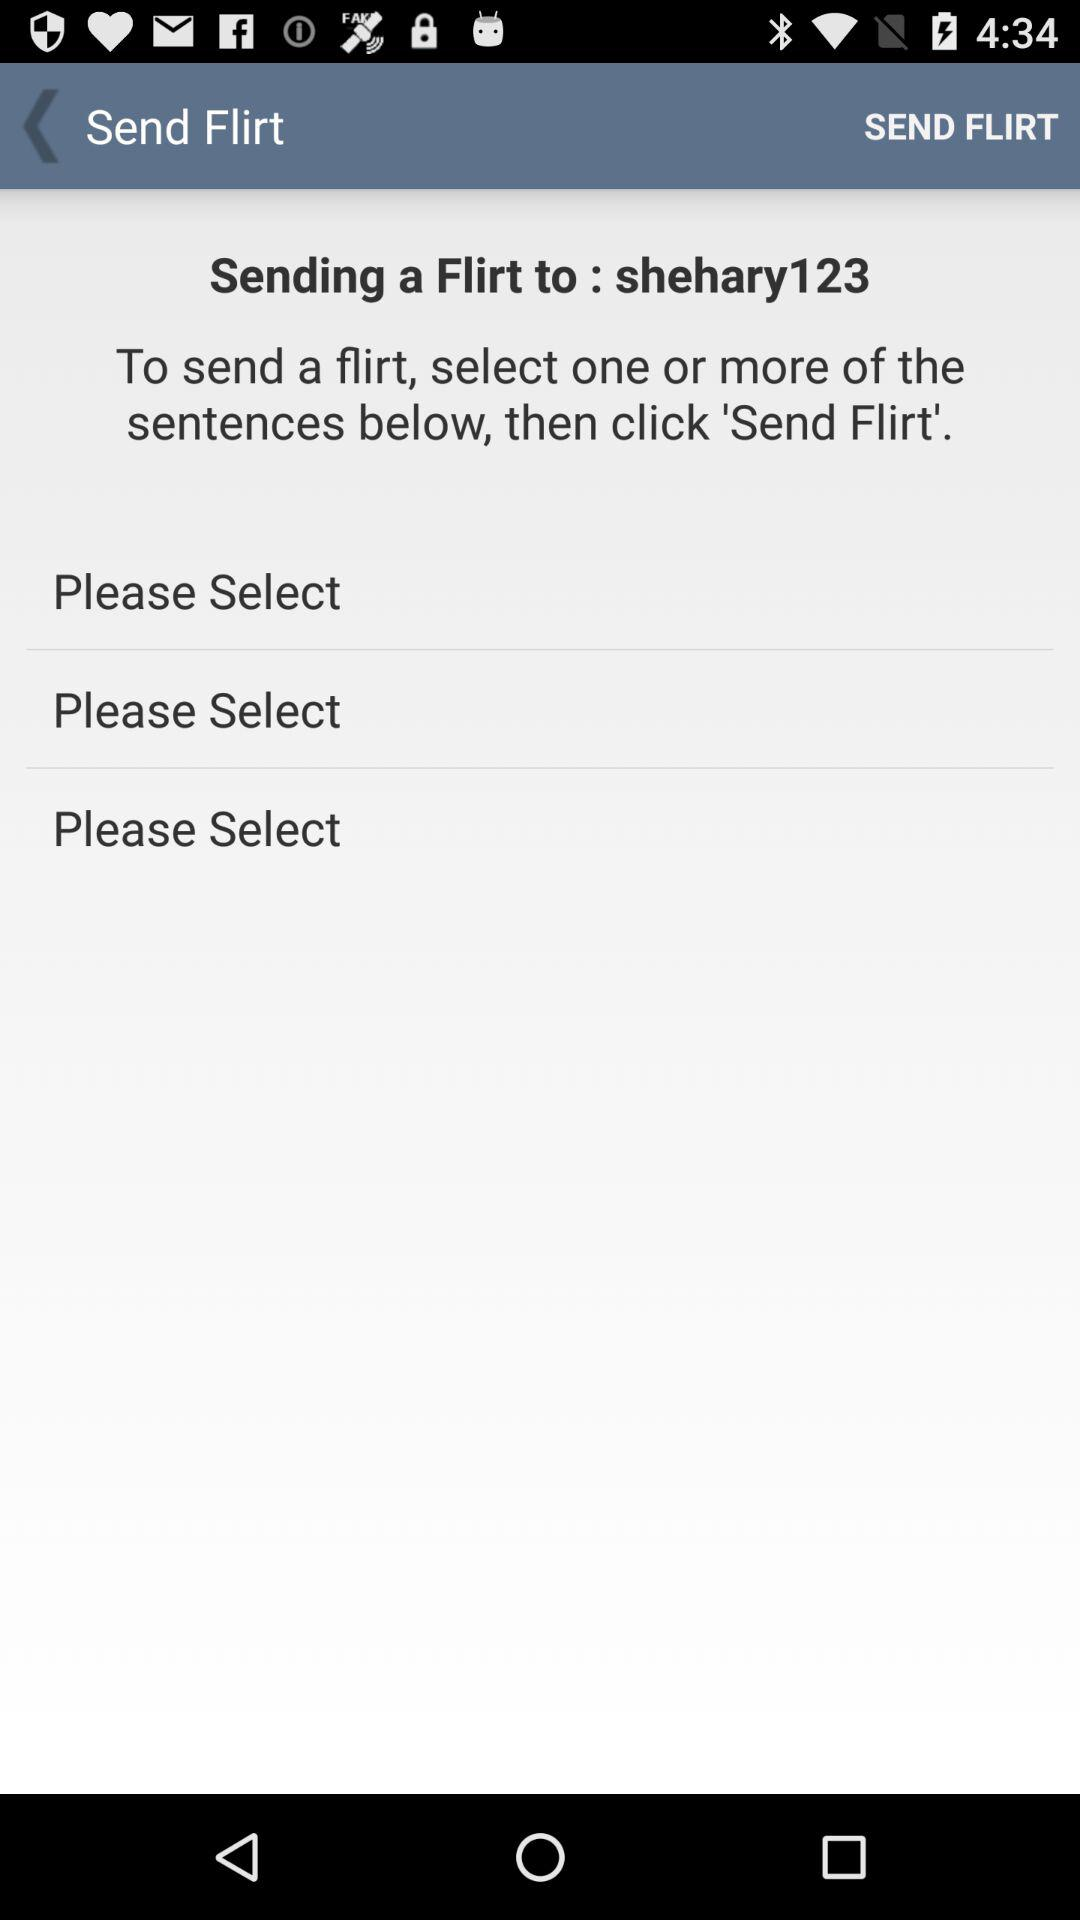How many sentences can be selected to send a flirt?
Answer the question using a single word or phrase. 3 